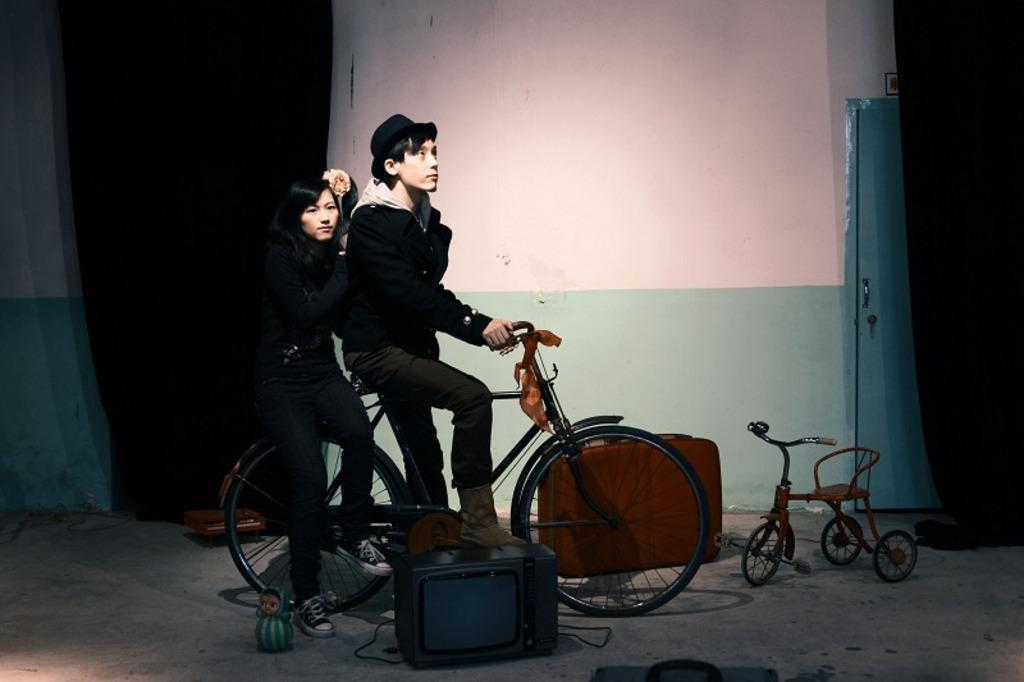Please provide a concise description of this image. In this picture i could see two persons riding a bike one of them sitting in the back and other sitting in front. Both are dressed up in black the other one is having hat and the back is having flower on her head. In the back ground i could see a white and green colored wall. 